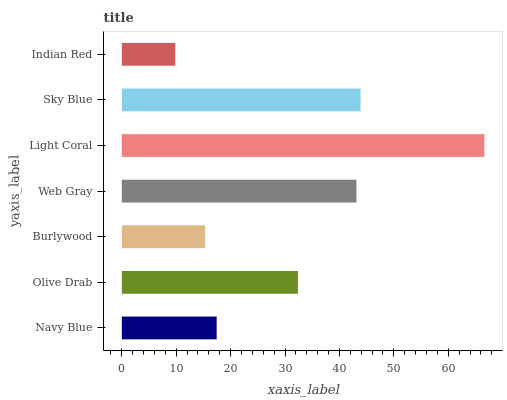Is Indian Red the minimum?
Answer yes or no. Yes. Is Light Coral the maximum?
Answer yes or no. Yes. Is Olive Drab the minimum?
Answer yes or no. No. Is Olive Drab the maximum?
Answer yes or no. No. Is Olive Drab greater than Navy Blue?
Answer yes or no. Yes. Is Navy Blue less than Olive Drab?
Answer yes or no. Yes. Is Navy Blue greater than Olive Drab?
Answer yes or no. No. Is Olive Drab less than Navy Blue?
Answer yes or no. No. Is Olive Drab the high median?
Answer yes or no. Yes. Is Olive Drab the low median?
Answer yes or no. Yes. Is Light Coral the high median?
Answer yes or no. No. Is Sky Blue the low median?
Answer yes or no. No. 